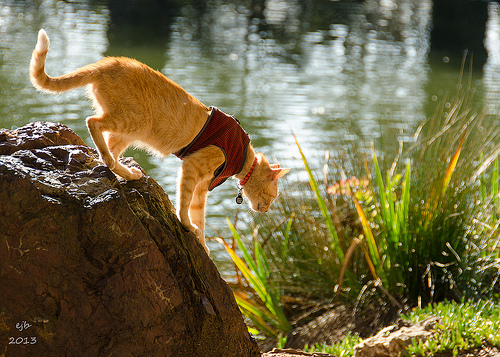<image>
Is the cat in the lake? No. The cat is not contained within the lake. These objects have a different spatial relationship. Is there a cat in the water? No. The cat is not contained within the water. These objects have a different spatial relationship. 